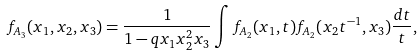Convert formula to latex. <formula><loc_0><loc_0><loc_500><loc_500>f _ { A _ { 3 } } ( x _ { 1 } , x _ { 2 } , x _ { 3 } ) = \frac { 1 } { 1 - q x _ { 1 } x _ { 2 } ^ { 2 } x _ { 3 } } \int f _ { A _ { 2 } } ( x _ { 1 } , t ) f _ { A _ { 2 } } ( x _ { 2 } t ^ { - 1 } , x _ { 3 } ) \frac { d t } { t } ,</formula> 